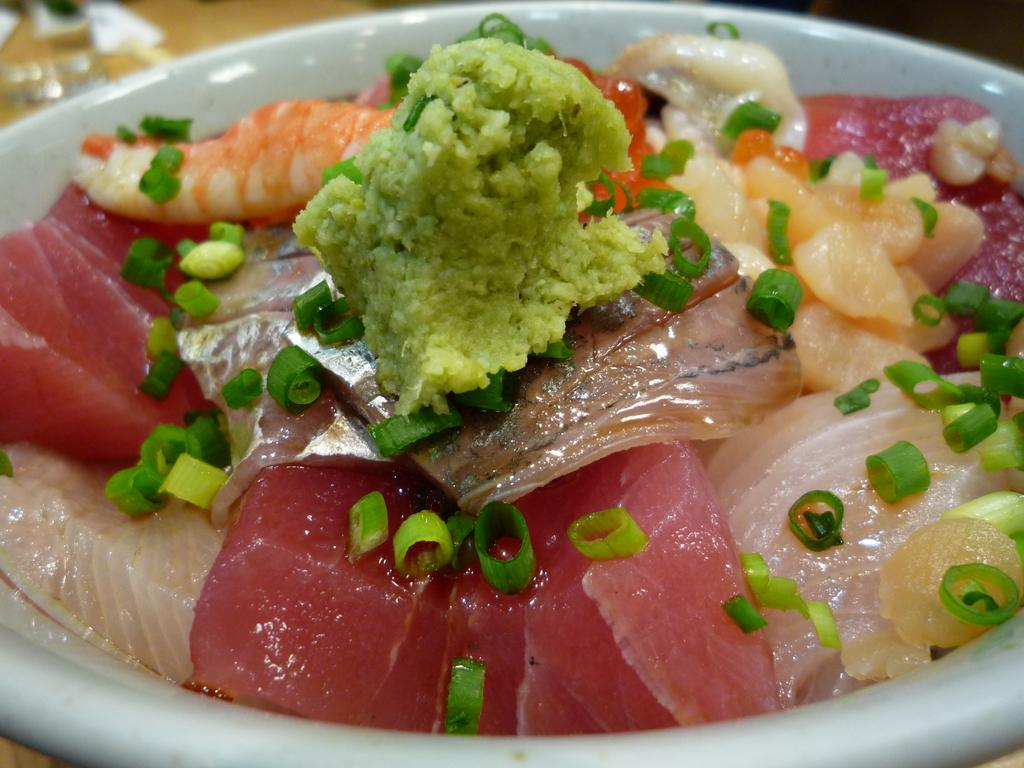What type of objects can be seen in the image? There are food items in the image. In what kind of container or object are the food items placed? The food items are in a white color object. What type of car can be seen in the image? There is no car present in the image; it only features food items in a white color object. 